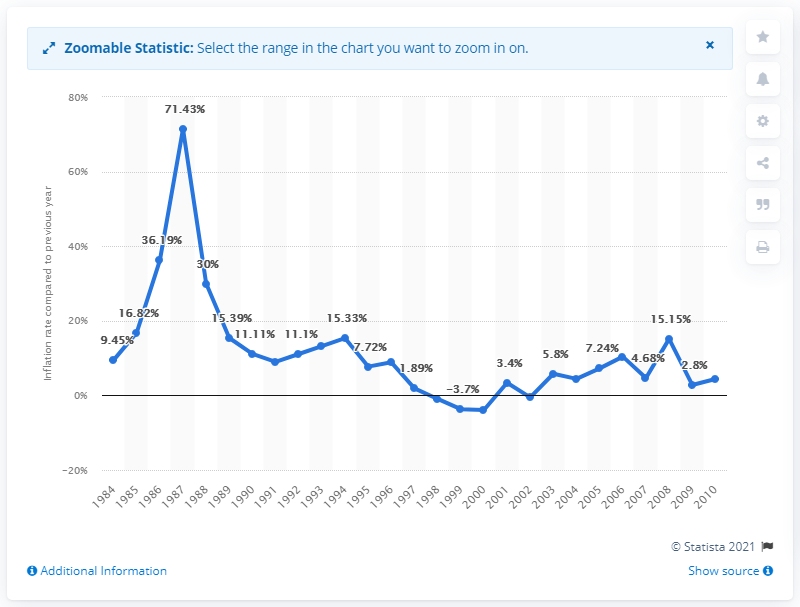Mention a couple of crucial points in this snapshot. The inflation rate in Syria in 2010 was 4.4%. 